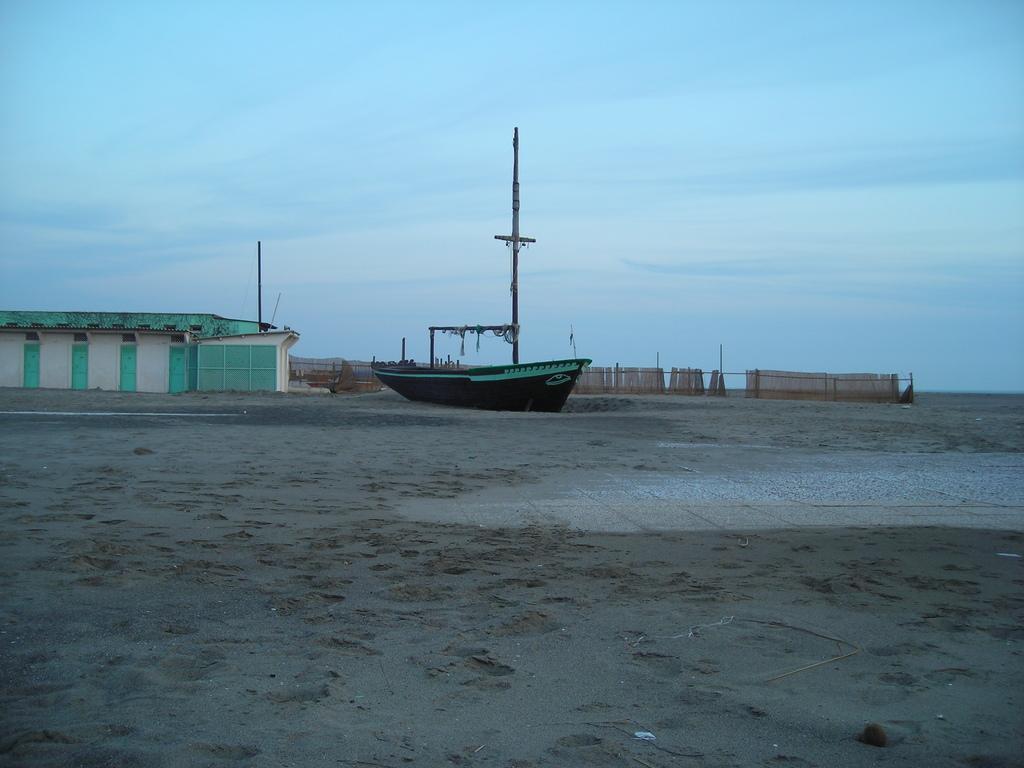Describe this image in one or two sentences. It is a boat in the middle. On the left it is a shed and at the top it is the sky. 